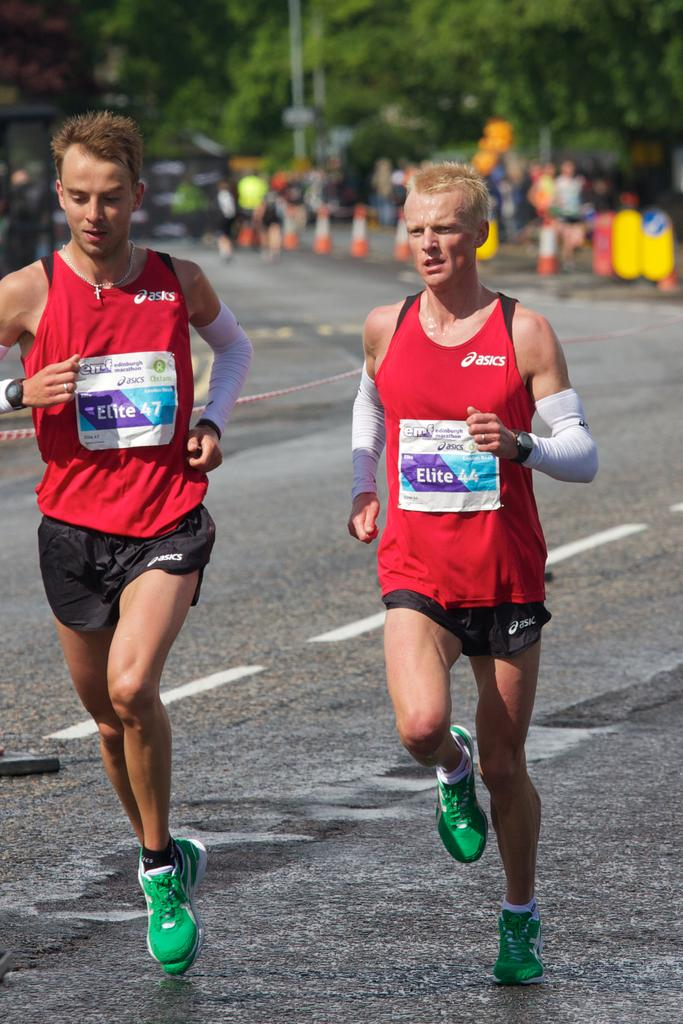<image>
Provide a brief description of the given image. A picture of 2 men running in asics tops and shorts 